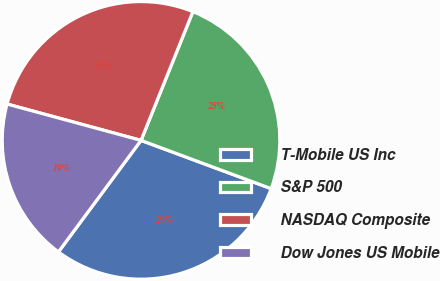Convert chart to OTSL. <chart><loc_0><loc_0><loc_500><loc_500><pie_chart><fcel>T-Mobile US Inc<fcel>S&P 500<fcel>NASDAQ Composite<fcel>Dow Jones US Mobile<nl><fcel>29.49%<fcel>24.56%<fcel>26.88%<fcel>19.07%<nl></chart> 